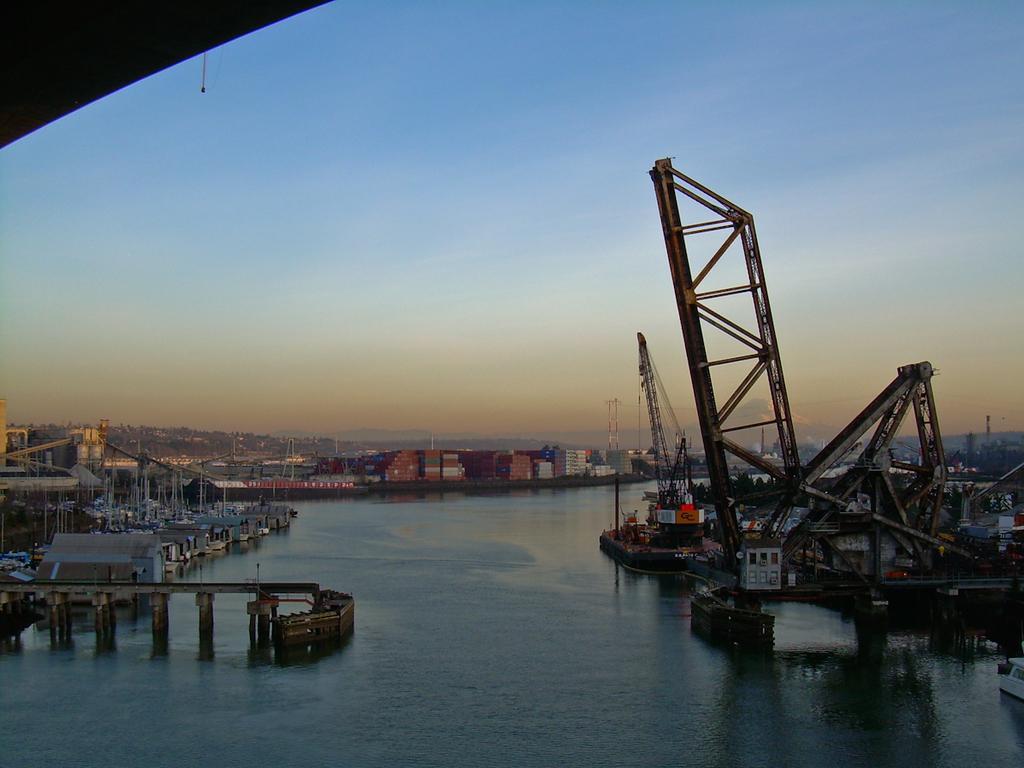Describe this image in one or two sentences. In this image we can see the shipyards on the water and we can see the bridge, rods and tower. In the background, we can see the sky. 